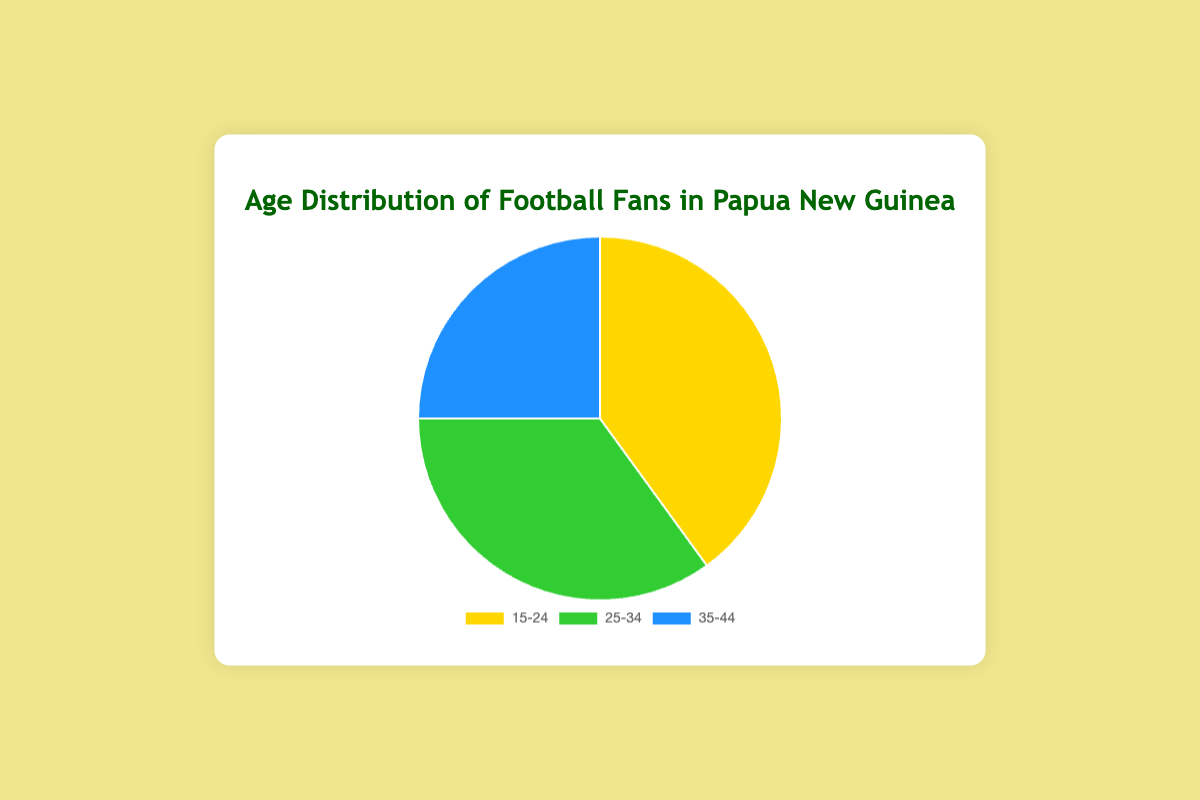Which age group has the largest percentage of football fans in Papua New Guinea? By looking at the pie chart, the 15-24 age group has the largest segment.
Answer: 15-24 Which age group has the smallest percentage of football fans in Papua New Guinea? By observing the pie chart, the 35-44 age group has the smallest segment.
Answer: 35-44 What is the difference in percentage between the 15-24 and 35-44 age groups? The 15-24 age group has 40%, and the 35-44 age group has 25%. The difference is 40% - 25%.
Answer: 15% How much larger is the percentage of fans in the 15-24 age group compared to the 25-34 age group? The 15-24 age group has 40%, and the 25-34 age group has 35%. The difference is 40% - 35%.
Answer: 5% What is the combined percentage of football fans in the 25-34 and 35-44 age groups? Adding the percentages of the 25-34 age group (35%) and the 35-44 age group (25%) results in 35% + 25%.
Answer: 60% Which age group's segment is represented in green in the pie chart? By referring to the visual attributes of the chart, the green segment represents the 25-34 age group.
Answer: 25-34 If the total number of football fans is 10,000, how many fans are in the 15-24 age group? Given 40% of fans are in the 15-24 age group, and there are 10,000 fans total, calculate 40% of 10,000.
Answer: 4,000 What is the average percentage of football fans across the three age groups? Sum the percentages of the three groups: 40% + 35% + 25% = 100%. Then divide by 3 to get the average.
Answer: 33.33% Which two age groups combined make up the majority of football fans? Adding the percentages of the largest two groups: 40% (15-24) + 35% (25-34) = 75%, which is more than half.
Answer: 15-24 and 25-34 Are there more football fans in the 25-34 or 35-44 age group? By comparing the percentages, 35% (25-34) is greater than 25% (35-44).
Answer: 25-34 